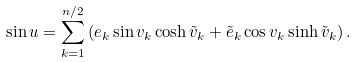Convert formula to latex. <formula><loc_0><loc_0><loc_500><loc_500>\sin u = \sum _ { k = 1 } ^ { n / 2 } \left ( e _ { k } \sin v _ { k } \cosh \tilde { v } _ { k } + \tilde { e } _ { k } \cos v _ { k } \sinh \tilde { v } _ { k } \right ) .</formula> 